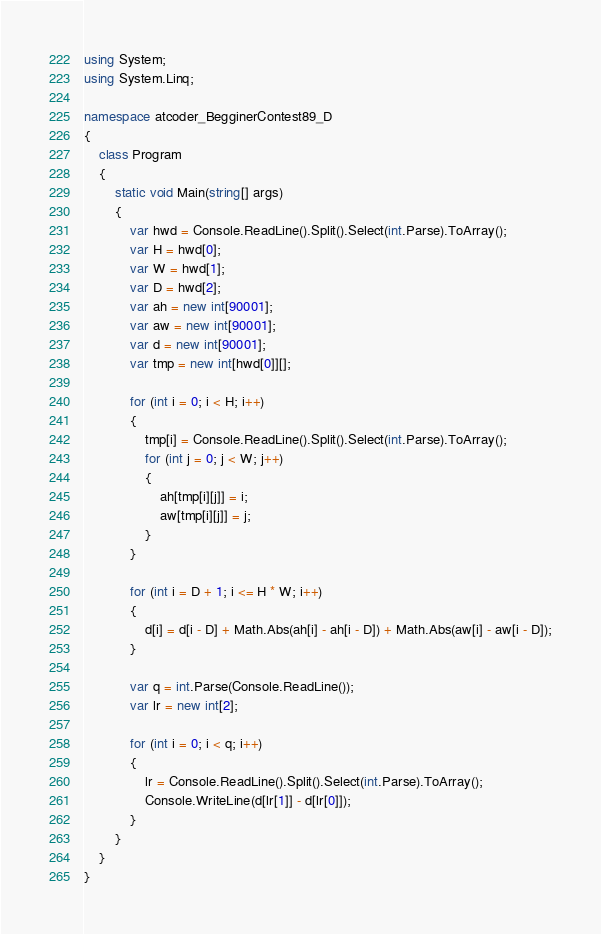Convert code to text. <code><loc_0><loc_0><loc_500><loc_500><_C#_>using System;
using System.Linq;

namespace atcoder_BegginerContest89_D
{
    class Program
    {
        static void Main(string[] args)
        {
            var hwd = Console.ReadLine().Split().Select(int.Parse).ToArray();
            var H = hwd[0];
            var W = hwd[1];
            var D = hwd[2];
            var ah = new int[90001];
            var aw = new int[90001];
            var d = new int[90001];
            var tmp = new int[hwd[0]][];

            for (int i = 0; i < H; i++)
            {
                tmp[i] = Console.ReadLine().Split().Select(int.Parse).ToArray();
                for (int j = 0; j < W; j++)
                {
                    ah[tmp[i][j]] = i;
                    aw[tmp[i][j]] = j;
                }
            }

            for (int i = D + 1; i <= H * W; i++)
            {
                d[i] = d[i - D] + Math.Abs(ah[i] - ah[i - D]) + Math.Abs(aw[i] - aw[i - D]);
            }

            var q = int.Parse(Console.ReadLine());
            var lr = new int[2];

            for (int i = 0; i < q; i++)
            {
                lr = Console.ReadLine().Split().Select(int.Parse).ToArray();
                Console.WriteLine(d[lr[1]] - d[lr[0]]);
            }
        }
    }
}
</code> 